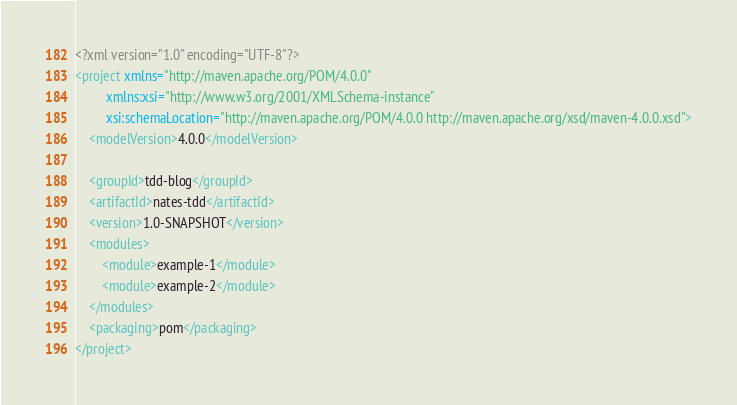<code> <loc_0><loc_0><loc_500><loc_500><_XML_><?xml version="1.0" encoding="UTF-8"?>
<project xmlns="http://maven.apache.org/POM/4.0.0"
         xmlns:xsi="http://www.w3.org/2001/XMLSchema-instance"
         xsi:schemaLocation="http://maven.apache.org/POM/4.0.0 http://maven.apache.org/xsd/maven-4.0.0.xsd">
    <modelVersion>4.0.0</modelVersion>

    <groupId>tdd-blog</groupId>
    <artifactId>nates-tdd</artifactId>
    <version>1.0-SNAPSHOT</version>
    <modules>
        <module>example-1</module>
        <module>example-2</module>
    </modules>
    <packaging>pom</packaging>
</project></code> 